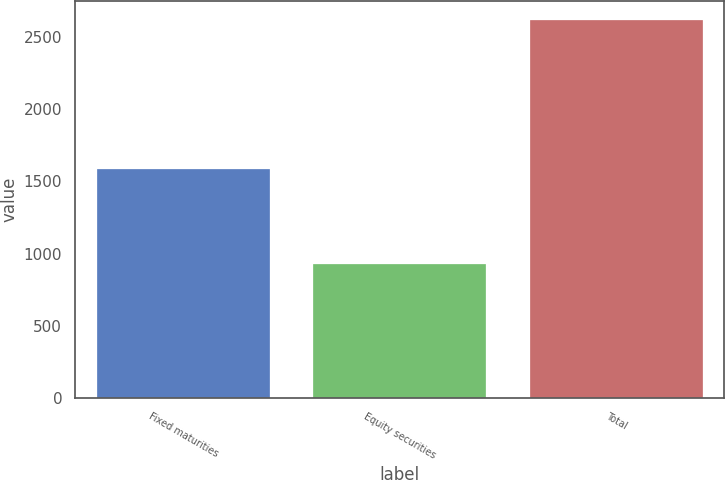Convert chart to OTSL. <chart><loc_0><loc_0><loc_500><loc_500><bar_chart><fcel>Fixed maturities<fcel>Equity securities<fcel>Total<nl><fcel>1586<fcel>930<fcel>2617<nl></chart> 